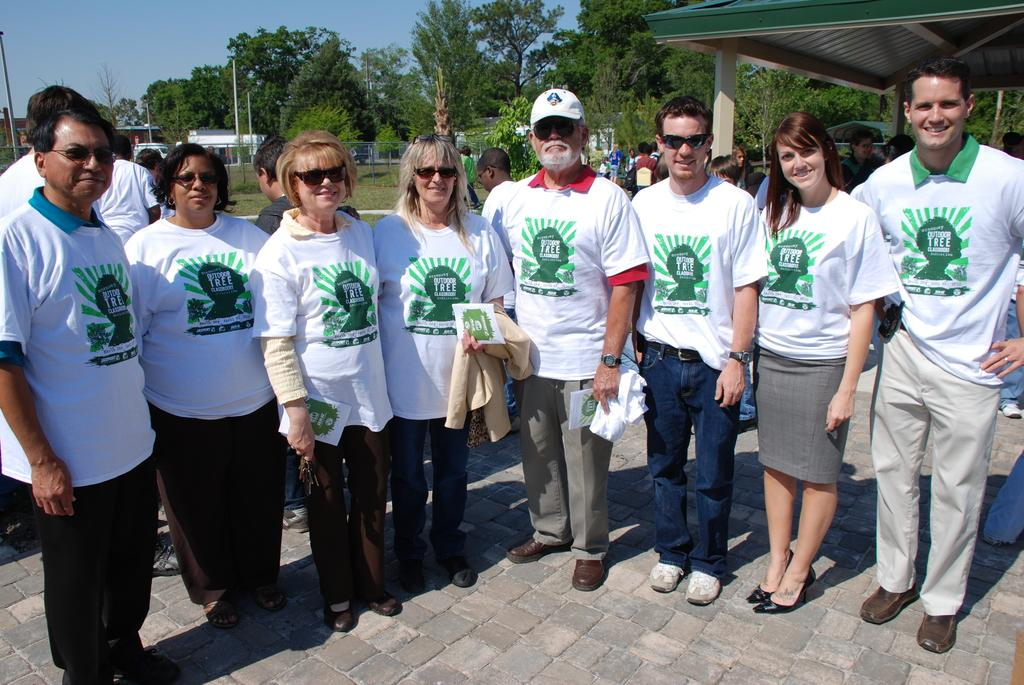How many people are in the image? There is a group of people standing in the image. Where are the people standing? The people are standing on the floor. What can be seen in the background of the image? There is a building, trees, and a shed in the background of the image. What type of chalk is being used by the ghost in the image? There is no ghost or chalk present in the image. How many fangs can be seen on the people in the image? There are no fangs visible on the people in the image. 